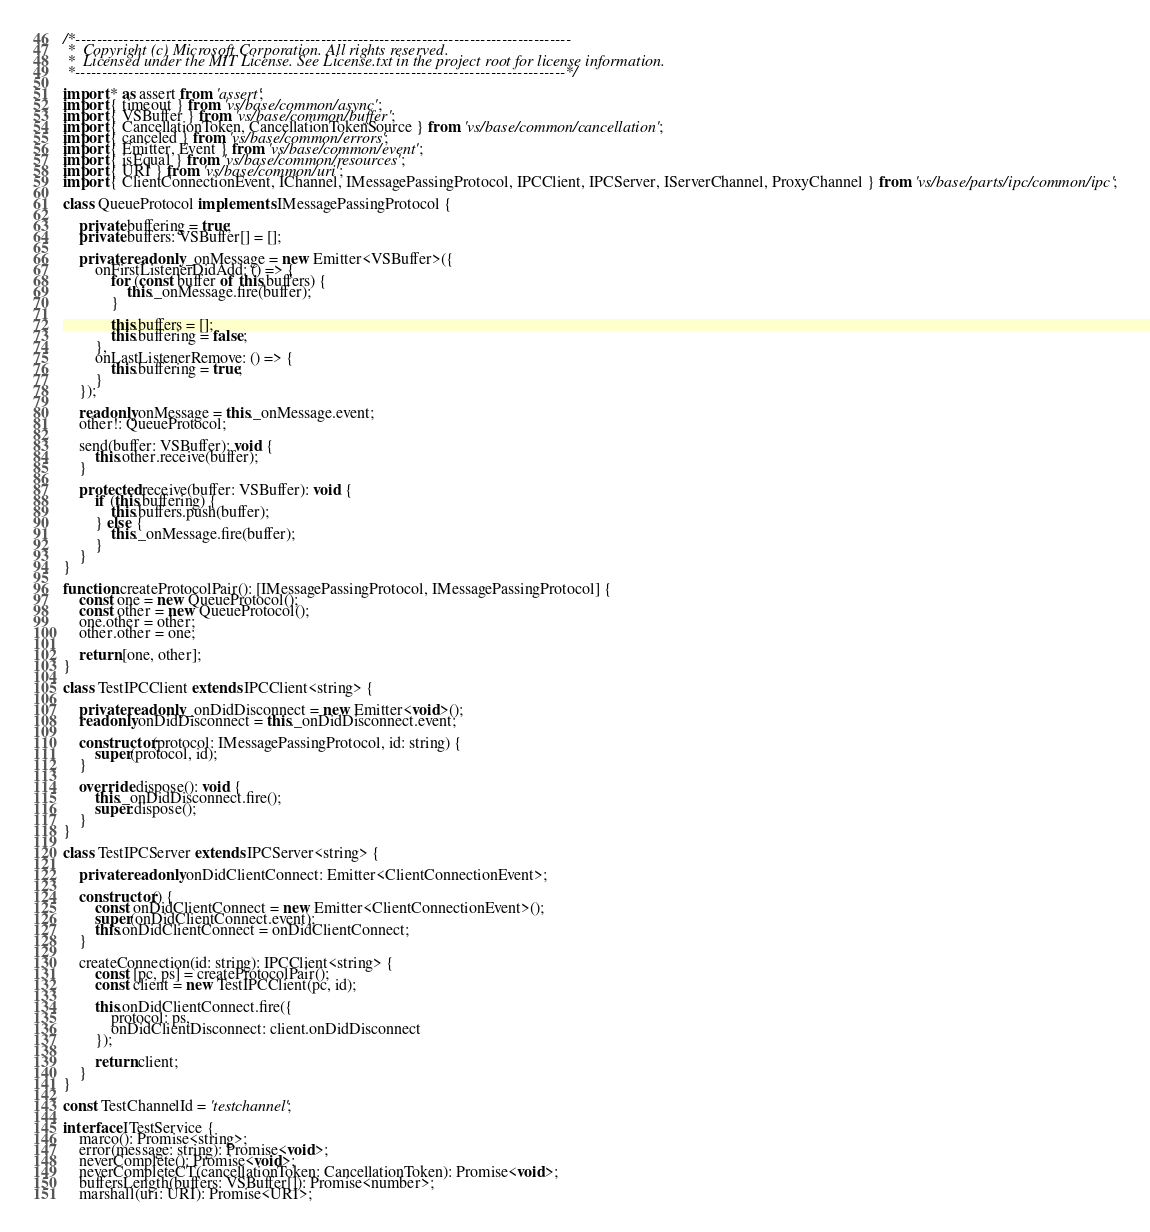Convert code to text. <code><loc_0><loc_0><loc_500><loc_500><_TypeScript_>/*---------------------------------------------------------------------------------------------
 *  Copyright (c) Microsoft Corporation. All rights reserved.
 *  Licensed under the MIT License. See License.txt in the project root for license information.
 *--------------------------------------------------------------------------------------------*/

import * as assert from 'assert';
import { timeout } from 'vs/base/common/async';
import { VSBuffer } from 'vs/base/common/buffer';
import { CancellationToken, CancellationTokenSource } from 'vs/base/common/cancellation';
import { canceled } from 'vs/base/common/errors';
import { Emitter, Event } from 'vs/base/common/event';
import { isEqual } from 'vs/base/common/resources';
import { URI } from 'vs/base/common/uri';
import { ClientConnectionEvent, IChannel, IMessagePassingProtocol, IPCClient, IPCServer, IServerChannel, ProxyChannel } from 'vs/base/parts/ipc/common/ipc';

class QueueProtocol implements IMessagePassingProtocol {

	private buffering = true;
	private buffers: VSBuffer[] = [];

	private readonly _onMessage = new Emitter<VSBuffer>({
		onFirstListenerDidAdd: () => {
			for (const buffer of this.buffers) {
				this._onMessage.fire(buffer);
			}

			this.buffers = [];
			this.buffering = false;
		},
		onLastListenerRemove: () => {
			this.buffering = true;
		}
	});

	readonly onMessage = this._onMessage.event;
	other!: QueueProtocol;

	send(buffer: VSBuffer): void {
		this.other.receive(buffer);
	}

	protected receive(buffer: VSBuffer): void {
		if (this.buffering) {
			this.buffers.push(buffer);
		} else {
			this._onMessage.fire(buffer);
		}
	}
}

function createProtocolPair(): [IMessagePassingProtocol, IMessagePassingProtocol] {
	const one = new QueueProtocol();
	const other = new QueueProtocol();
	one.other = other;
	other.other = one;

	return [one, other];
}

class TestIPCClient extends IPCClient<string> {

	private readonly _onDidDisconnect = new Emitter<void>();
	readonly onDidDisconnect = this._onDidDisconnect.event;

	constructor(protocol: IMessagePassingProtocol, id: string) {
		super(protocol, id);
	}

	override dispose(): void {
		this._onDidDisconnect.fire();
		super.dispose();
	}
}

class TestIPCServer extends IPCServer<string> {

	private readonly onDidClientConnect: Emitter<ClientConnectionEvent>;

	constructor() {
		const onDidClientConnect = new Emitter<ClientConnectionEvent>();
		super(onDidClientConnect.event);
		this.onDidClientConnect = onDidClientConnect;
	}

	createConnection(id: string): IPCClient<string> {
		const [pc, ps] = createProtocolPair();
		const client = new TestIPCClient(pc, id);

		this.onDidClientConnect.fire({
			protocol: ps,
			onDidClientDisconnect: client.onDidDisconnect
		});

		return client;
	}
}

const TestChannelId = 'testchannel';

interface ITestService {
	marco(): Promise<string>;
	error(message: string): Promise<void>;
	neverComplete(): Promise<void>;
	neverCompleteCT(cancellationToken: CancellationToken): Promise<void>;
	buffersLength(buffers: VSBuffer[]): Promise<number>;
	marshall(uri: URI): Promise<URI>;</code> 